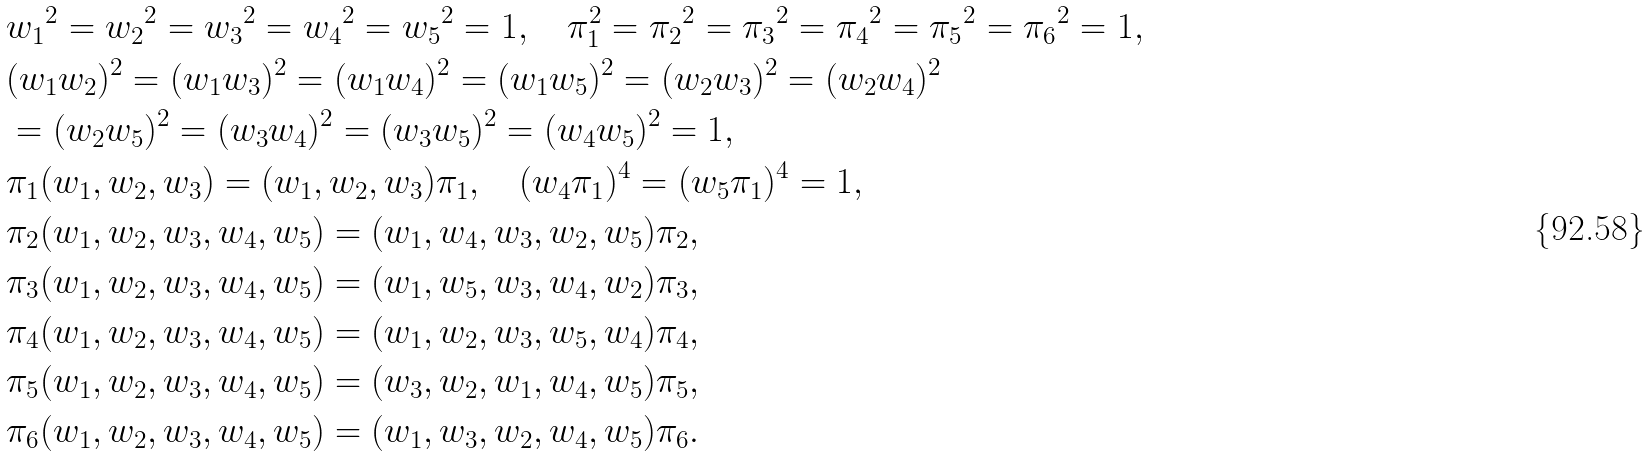Convert formula to latex. <formula><loc_0><loc_0><loc_500><loc_500>& { w _ { 1 } } ^ { 2 } = { w _ { 2 } } ^ { 2 } = { w _ { 3 } } ^ { 2 } = { w _ { 4 } } ^ { 2 } = { w _ { 5 } } ^ { 2 } = 1 , \quad { \pi } _ { 1 } ^ { 2 } = { { \pi } _ { 2 } } ^ { 2 } = { { \pi } _ { 3 } } ^ { 2 } = { { \pi } _ { 4 } } ^ { 2 } = { { \pi } _ { 5 } } ^ { 2 } = { { \pi } _ { 6 } } ^ { 2 } = 1 , \\ & ( w _ { 1 } w _ { 2 } ) ^ { 2 } = ( w _ { 1 } w _ { 3 } ) ^ { 2 } = ( w _ { 1 } w _ { 4 } ) ^ { 2 } = ( w _ { 1 } w _ { 5 } ) ^ { 2 } = ( w _ { 2 } w _ { 3 } ) ^ { 2 } = ( w _ { 2 } w _ { 4 } ) ^ { 2 } \\ & = ( w _ { 2 } w _ { 5 } ) ^ { 2 } = ( w _ { 3 } w _ { 4 } ) ^ { 2 } = ( w _ { 3 } w _ { 5 } ) ^ { 2 } = ( w _ { 4 } w _ { 5 } ) ^ { 2 } = 1 , \\ & { \pi _ { 1 } } ( w _ { 1 } , w _ { 2 } , w _ { 3 } ) = ( w _ { 1 } , w _ { 2 } , w _ { 3 } ) { \pi _ { 1 } } , \quad ( w _ { 4 } \pi _ { 1 } ) ^ { 4 } = ( w _ { 5 } \pi _ { 1 } ) ^ { 4 } = 1 , \\ & { \pi } _ { 2 } ( w _ { 1 } , w _ { 2 } , w _ { 3 } , w _ { 4 } , w _ { 5 } ) = ( w _ { 1 } , w _ { 4 } , w _ { 3 } , w _ { 2 } , w _ { 5 } ) { \pi } _ { 2 } , \\ & { \pi } _ { 3 } ( w _ { 1 } , w _ { 2 } , w _ { 3 } , w _ { 4 } , w _ { 5 } ) = ( w _ { 1 } , w _ { 5 } , w _ { 3 } , w _ { 4 } , w _ { 2 } ) { \pi } _ { 3 } , \\ & { \pi } _ { 4 } ( w _ { 1 } , w _ { 2 } , w _ { 3 } , w _ { 4 } , w _ { 5 } ) = ( w _ { 1 } , w _ { 2 } , w _ { 3 } , w _ { 5 } , w _ { 4 } ) { \pi } _ { 4 } , \\ & { \pi } _ { 5 } ( w _ { 1 } , w _ { 2 } , w _ { 3 } , w _ { 4 } , w _ { 5 } ) = ( w _ { 3 } , w _ { 2 } , w _ { 1 } , w _ { 4 } , w _ { 5 } ) { \pi } _ { 5 } , \\ & { \pi } _ { 6 } ( w _ { 1 } , w _ { 2 } , w _ { 3 } , w _ { 4 } , w _ { 5 } ) = ( w _ { 1 } , w _ { 3 } , w _ { 2 } , w _ { 4 } , w _ { 5 } ) { \pi } _ { 6 } .</formula> 